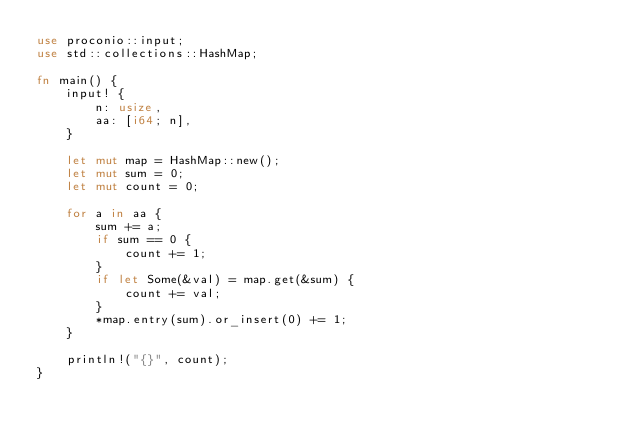Convert code to text. <code><loc_0><loc_0><loc_500><loc_500><_Rust_>use proconio::input;
use std::collections::HashMap;

fn main() {
    input! {
        n: usize,
        aa: [i64; n],
    }

    let mut map = HashMap::new();
    let mut sum = 0;
    let mut count = 0;

    for a in aa {
        sum += a;
        if sum == 0 {
            count += 1;
        }
        if let Some(&val) = map.get(&sum) {
            count += val;
        }
        *map.entry(sum).or_insert(0) += 1;
    }

    println!("{}", count);
}
</code> 